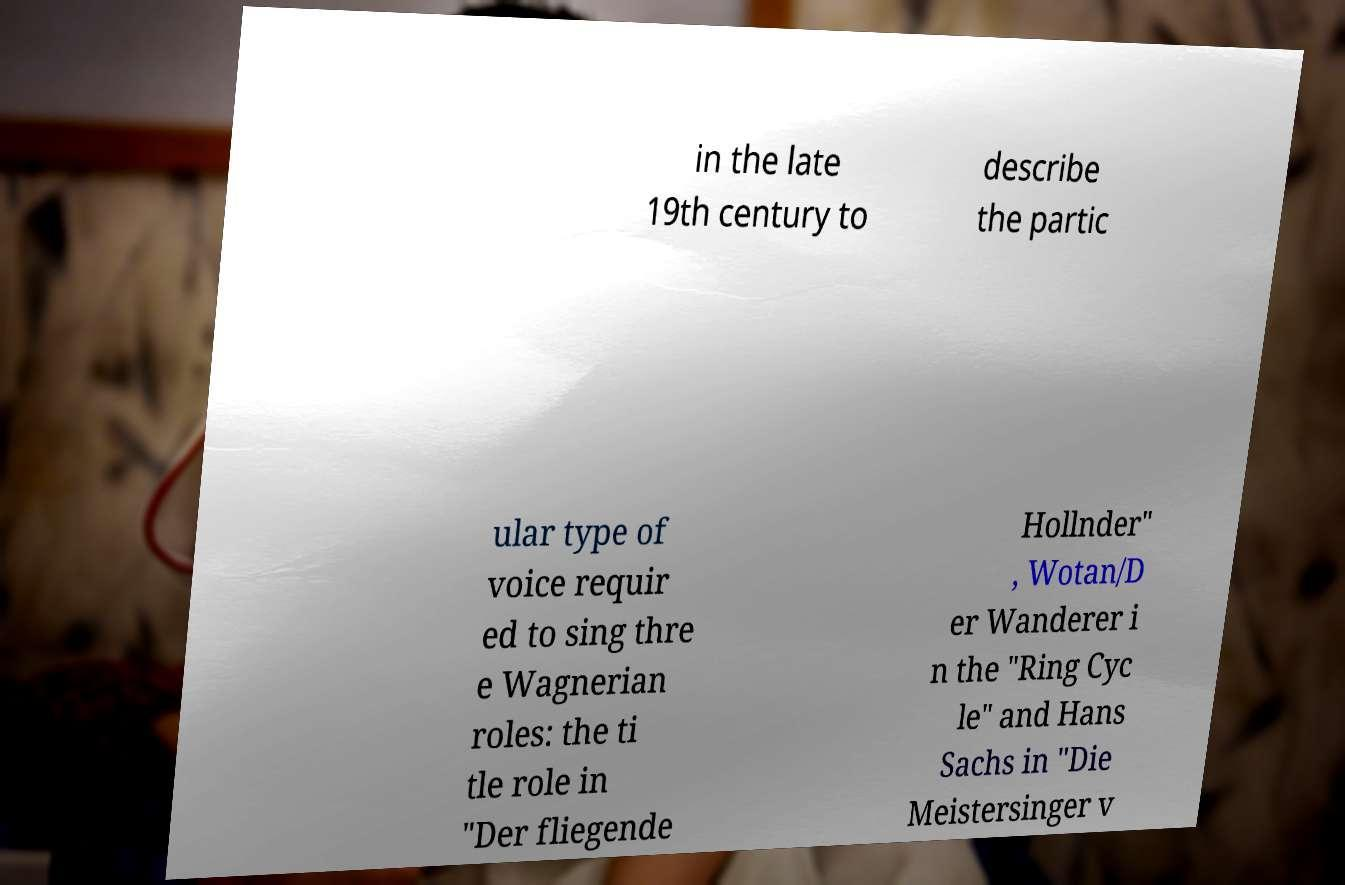Can you accurately transcribe the text from the provided image for me? in the late 19th century to describe the partic ular type of voice requir ed to sing thre e Wagnerian roles: the ti tle role in "Der fliegende Hollnder" , Wotan/D er Wanderer i n the "Ring Cyc le" and Hans Sachs in "Die Meistersinger v 